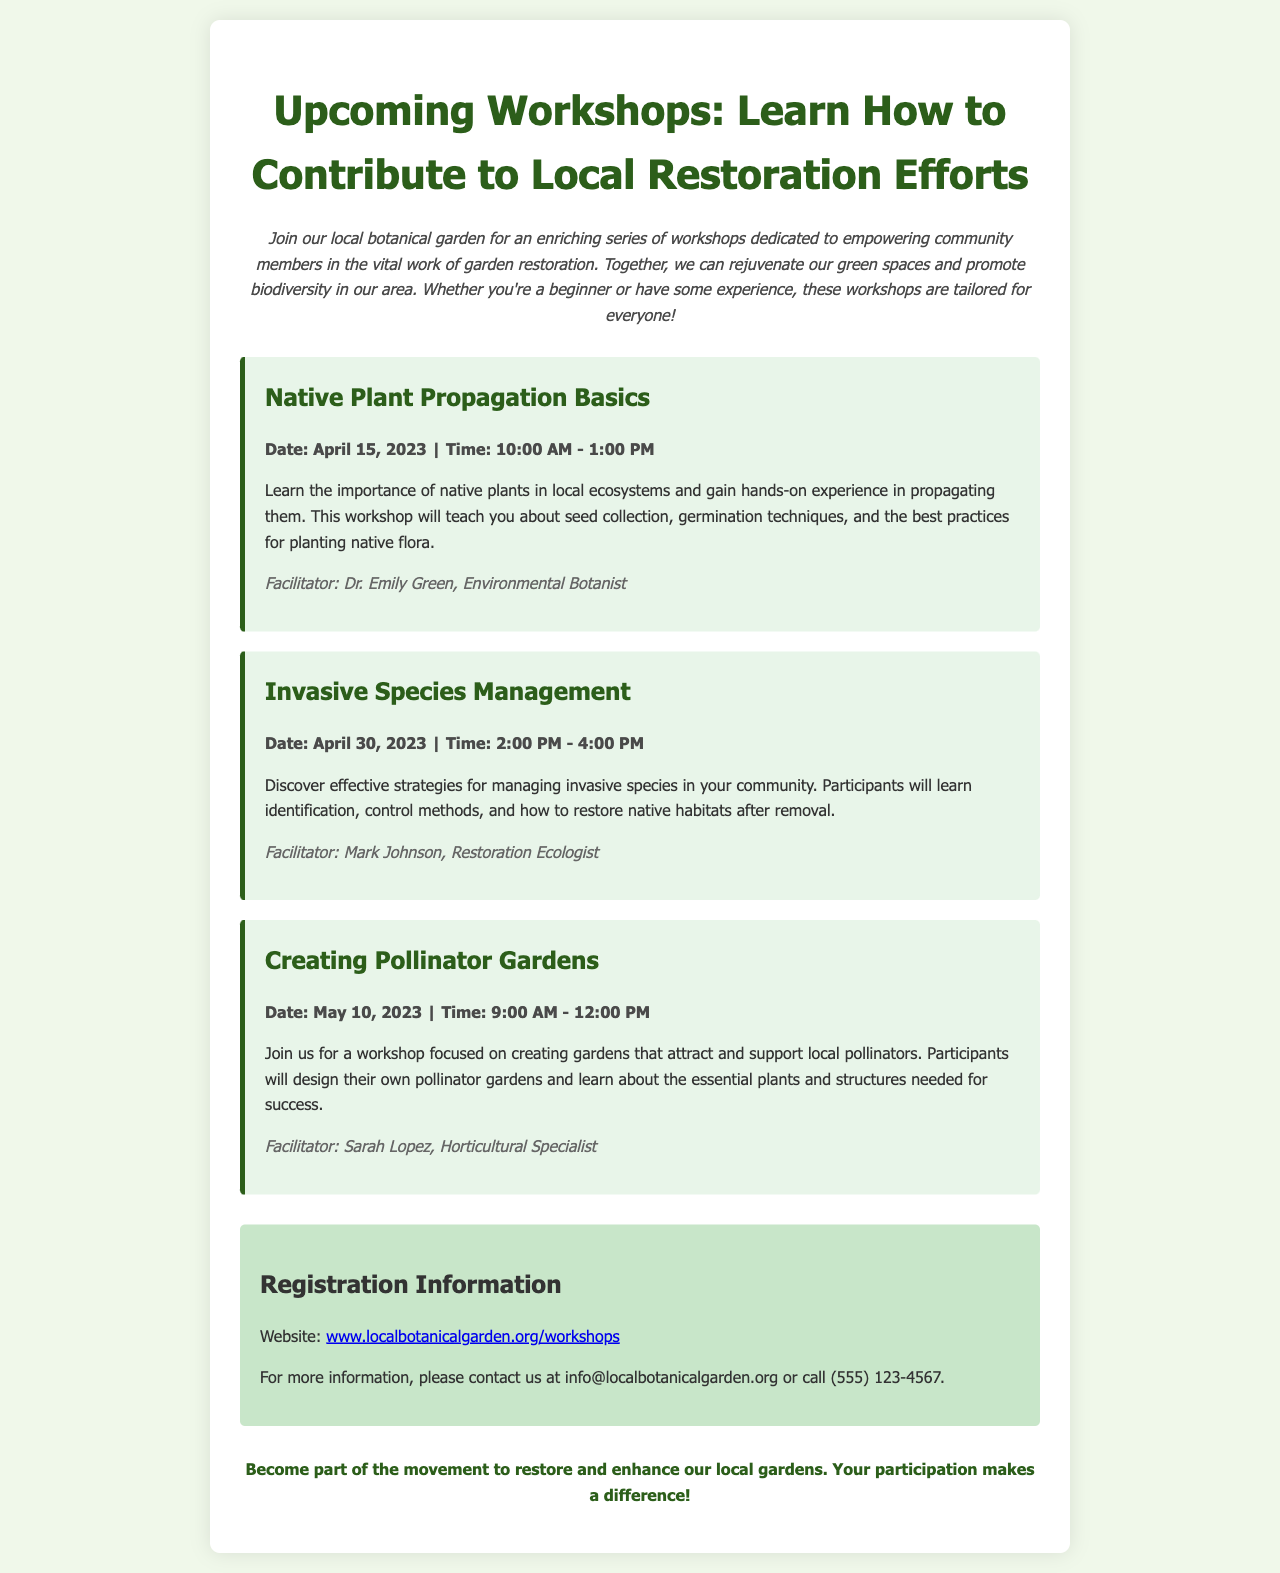What is the title of the brochure? The title appears at the top of the document and is the main topic addressed.
Answer: Upcoming Workshops: Learn How to Contribute to Local Restoration Efforts When is the Native Plant Propagation Basics workshop scheduled? The date is provided in the workshop section for Native Plant Propagation Basics.
Answer: April 15, 2023 Who is the facilitator for the Invasive Species Management workshop? The facilitator's name is listed in the workshop details for Invasive Species Management.
Answer: Mark Johnson What time does the Creating Pollinator Gardens workshop start? The start time is mentioned in the workshop details of Creating Pollinator Gardens.
Answer: 9:00 AM What is the main focus of the workshop series? This summarizes the purpose of the workshops as stated in the introduction of the brochure.
Answer: Garden restoration How long is the Invasive Species Management workshop? The total duration is calculated based on the start and end times provided in the workshop details.
Answer: 2 hours What is the provided website for registration? The website for registration is explicitly stated in the registration section of the brochure.
Answer: www.localbotanicalgarden.org/workshops What is emphasized in the footer of the brochure? The footer highlights the importance of participation in local garden restoration efforts.
Answer: Participation makes a difference Which workshop focuses on seed collection and germination techniques? This refers to the specific workshop that teaches about these techniques as mentioned in the description.
Answer: Native Plant Propagation Basics 